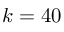Convert formula to latex. <formula><loc_0><loc_0><loc_500><loc_500>k = 4 0</formula> 